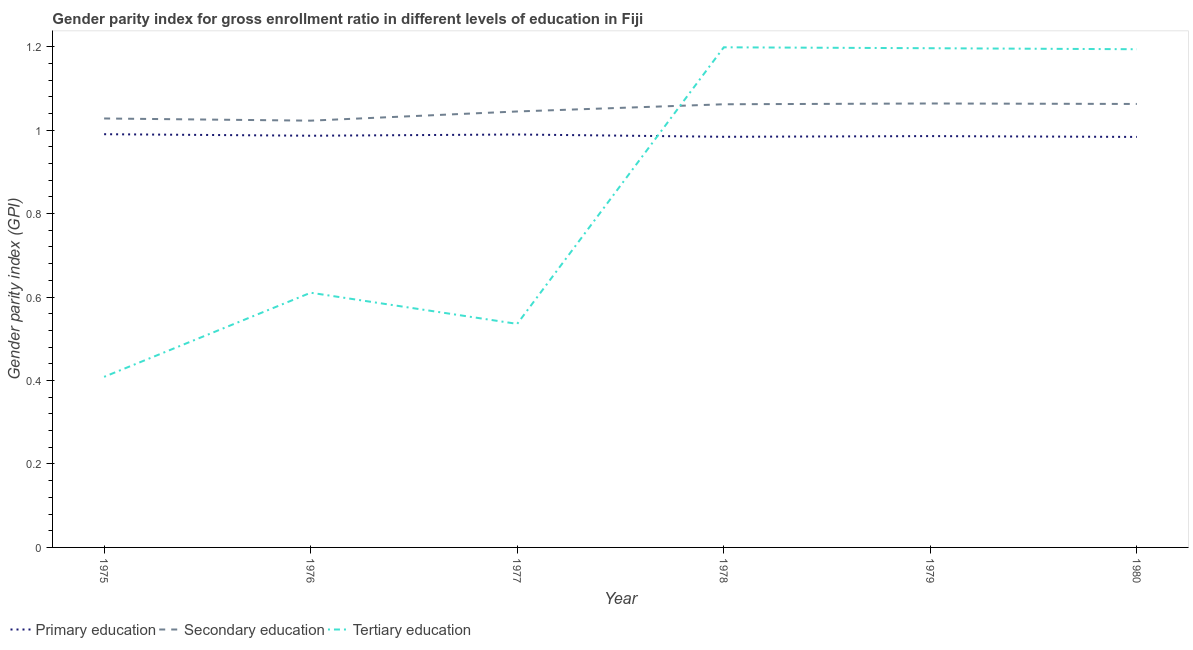How many different coloured lines are there?
Ensure brevity in your answer.  3. What is the gender parity index in tertiary education in 1976?
Your answer should be compact. 0.61. Across all years, what is the maximum gender parity index in secondary education?
Offer a very short reply. 1.06. Across all years, what is the minimum gender parity index in secondary education?
Offer a terse response. 1.02. In which year was the gender parity index in tertiary education maximum?
Ensure brevity in your answer.  1978. In which year was the gender parity index in primary education minimum?
Offer a terse response. 1980. What is the total gender parity index in primary education in the graph?
Offer a terse response. 5.92. What is the difference between the gender parity index in tertiary education in 1977 and that in 1979?
Ensure brevity in your answer.  -0.66. What is the difference between the gender parity index in primary education in 1975 and the gender parity index in tertiary education in 1978?
Your answer should be compact. -0.21. What is the average gender parity index in tertiary education per year?
Offer a terse response. 0.86. In the year 1975, what is the difference between the gender parity index in tertiary education and gender parity index in secondary education?
Ensure brevity in your answer.  -0.62. In how many years, is the gender parity index in secondary education greater than 1.04?
Your response must be concise. 4. What is the ratio of the gender parity index in tertiary education in 1979 to that in 1980?
Offer a very short reply. 1. Is the gender parity index in tertiary education in 1977 less than that in 1978?
Ensure brevity in your answer.  Yes. What is the difference between the highest and the second highest gender parity index in tertiary education?
Provide a short and direct response. 0. What is the difference between the highest and the lowest gender parity index in primary education?
Ensure brevity in your answer.  0.01. Is the sum of the gender parity index in secondary education in 1976 and 1978 greater than the maximum gender parity index in primary education across all years?
Make the answer very short. Yes. Does the gender parity index in secondary education monotonically increase over the years?
Provide a short and direct response. No. Is the gender parity index in secondary education strictly less than the gender parity index in tertiary education over the years?
Your answer should be very brief. No. What is the difference between two consecutive major ticks on the Y-axis?
Provide a short and direct response. 0.2. Are the values on the major ticks of Y-axis written in scientific E-notation?
Make the answer very short. No. Does the graph contain any zero values?
Keep it short and to the point. No. Does the graph contain grids?
Give a very brief answer. No. How are the legend labels stacked?
Offer a terse response. Horizontal. What is the title of the graph?
Ensure brevity in your answer.  Gender parity index for gross enrollment ratio in different levels of education in Fiji. What is the label or title of the X-axis?
Your answer should be very brief. Year. What is the label or title of the Y-axis?
Your answer should be very brief. Gender parity index (GPI). What is the Gender parity index (GPI) of Primary education in 1975?
Offer a terse response. 0.99. What is the Gender parity index (GPI) of Secondary education in 1975?
Provide a succinct answer. 1.03. What is the Gender parity index (GPI) in Tertiary education in 1975?
Offer a terse response. 0.41. What is the Gender parity index (GPI) in Primary education in 1976?
Ensure brevity in your answer.  0.99. What is the Gender parity index (GPI) in Secondary education in 1976?
Ensure brevity in your answer.  1.02. What is the Gender parity index (GPI) in Tertiary education in 1976?
Provide a short and direct response. 0.61. What is the Gender parity index (GPI) of Primary education in 1977?
Give a very brief answer. 0.99. What is the Gender parity index (GPI) of Secondary education in 1977?
Make the answer very short. 1.04. What is the Gender parity index (GPI) of Tertiary education in 1977?
Offer a terse response. 0.54. What is the Gender parity index (GPI) of Primary education in 1978?
Give a very brief answer. 0.98. What is the Gender parity index (GPI) of Secondary education in 1978?
Your answer should be compact. 1.06. What is the Gender parity index (GPI) of Tertiary education in 1978?
Keep it short and to the point. 1.2. What is the Gender parity index (GPI) of Primary education in 1979?
Keep it short and to the point. 0.99. What is the Gender parity index (GPI) of Secondary education in 1979?
Give a very brief answer. 1.06. What is the Gender parity index (GPI) of Tertiary education in 1979?
Keep it short and to the point. 1.2. What is the Gender parity index (GPI) of Primary education in 1980?
Your answer should be very brief. 0.98. What is the Gender parity index (GPI) in Secondary education in 1980?
Make the answer very short. 1.06. What is the Gender parity index (GPI) of Tertiary education in 1980?
Keep it short and to the point. 1.19. Across all years, what is the maximum Gender parity index (GPI) of Primary education?
Your answer should be very brief. 0.99. Across all years, what is the maximum Gender parity index (GPI) in Secondary education?
Give a very brief answer. 1.06. Across all years, what is the maximum Gender parity index (GPI) in Tertiary education?
Offer a terse response. 1.2. Across all years, what is the minimum Gender parity index (GPI) of Primary education?
Your response must be concise. 0.98. Across all years, what is the minimum Gender parity index (GPI) of Secondary education?
Provide a short and direct response. 1.02. Across all years, what is the minimum Gender parity index (GPI) in Tertiary education?
Keep it short and to the point. 0.41. What is the total Gender parity index (GPI) of Primary education in the graph?
Your answer should be very brief. 5.92. What is the total Gender parity index (GPI) of Secondary education in the graph?
Keep it short and to the point. 6.28. What is the total Gender parity index (GPI) in Tertiary education in the graph?
Keep it short and to the point. 5.14. What is the difference between the Gender parity index (GPI) of Primary education in 1975 and that in 1976?
Give a very brief answer. 0. What is the difference between the Gender parity index (GPI) in Secondary education in 1975 and that in 1976?
Your answer should be very brief. 0.01. What is the difference between the Gender parity index (GPI) in Tertiary education in 1975 and that in 1976?
Make the answer very short. -0.2. What is the difference between the Gender parity index (GPI) in Primary education in 1975 and that in 1977?
Your answer should be very brief. 0. What is the difference between the Gender parity index (GPI) in Secondary education in 1975 and that in 1977?
Give a very brief answer. -0.02. What is the difference between the Gender parity index (GPI) of Tertiary education in 1975 and that in 1977?
Provide a succinct answer. -0.13. What is the difference between the Gender parity index (GPI) in Primary education in 1975 and that in 1978?
Make the answer very short. 0.01. What is the difference between the Gender parity index (GPI) in Secondary education in 1975 and that in 1978?
Provide a succinct answer. -0.03. What is the difference between the Gender parity index (GPI) of Tertiary education in 1975 and that in 1978?
Keep it short and to the point. -0.79. What is the difference between the Gender parity index (GPI) in Primary education in 1975 and that in 1979?
Your response must be concise. 0. What is the difference between the Gender parity index (GPI) of Secondary education in 1975 and that in 1979?
Your response must be concise. -0.04. What is the difference between the Gender parity index (GPI) in Tertiary education in 1975 and that in 1979?
Offer a very short reply. -0.79. What is the difference between the Gender parity index (GPI) in Primary education in 1975 and that in 1980?
Offer a very short reply. 0.01. What is the difference between the Gender parity index (GPI) of Secondary education in 1975 and that in 1980?
Ensure brevity in your answer.  -0.03. What is the difference between the Gender parity index (GPI) in Tertiary education in 1975 and that in 1980?
Keep it short and to the point. -0.79. What is the difference between the Gender parity index (GPI) in Primary education in 1976 and that in 1977?
Your answer should be compact. -0. What is the difference between the Gender parity index (GPI) in Secondary education in 1976 and that in 1977?
Offer a very short reply. -0.02. What is the difference between the Gender parity index (GPI) of Tertiary education in 1976 and that in 1977?
Your answer should be compact. 0.07. What is the difference between the Gender parity index (GPI) in Primary education in 1976 and that in 1978?
Your response must be concise. 0. What is the difference between the Gender parity index (GPI) of Secondary education in 1976 and that in 1978?
Keep it short and to the point. -0.04. What is the difference between the Gender parity index (GPI) of Tertiary education in 1976 and that in 1978?
Keep it short and to the point. -0.59. What is the difference between the Gender parity index (GPI) in Primary education in 1976 and that in 1979?
Ensure brevity in your answer.  0. What is the difference between the Gender parity index (GPI) of Secondary education in 1976 and that in 1979?
Offer a terse response. -0.04. What is the difference between the Gender parity index (GPI) in Tertiary education in 1976 and that in 1979?
Your response must be concise. -0.59. What is the difference between the Gender parity index (GPI) of Primary education in 1976 and that in 1980?
Your answer should be compact. 0. What is the difference between the Gender parity index (GPI) of Secondary education in 1976 and that in 1980?
Provide a succinct answer. -0.04. What is the difference between the Gender parity index (GPI) of Tertiary education in 1976 and that in 1980?
Provide a short and direct response. -0.58. What is the difference between the Gender parity index (GPI) of Primary education in 1977 and that in 1978?
Keep it short and to the point. 0.01. What is the difference between the Gender parity index (GPI) of Secondary education in 1977 and that in 1978?
Provide a succinct answer. -0.02. What is the difference between the Gender parity index (GPI) in Tertiary education in 1977 and that in 1978?
Offer a very short reply. -0.66. What is the difference between the Gender parity index (GPI) in Primary education in 1977 and that in 1979?
Keep it short and to the point. 0. What is the difference between the Gender parity index (GPI) in Secondary education in 1977 and that in 1979?
Keep it short and to the point. -0.02. What is the difference between the Gender parity index (GPI) in Tertiary education in 1977 and that in 1979?
Provide a short and direct response. -0.66. What is the difference between the Gender parity index (GPI) of Primary education in 1977 and that in 1980?
Your response must be concise. 0.01. What is the difference between the Gender parity index (GPI) in Secondary education in 1977 and that in 1980?
Offer a terse response. -0.02. What is the difference between the Gender parity index (GPI) in Tertiary education in 1977 and that in 1980?
Offer a very short reply. -0.66. What is the difference between the Gender parity index (GPI) in Primary education in 1978 and that in 1979?
Offer a terse response. -0. What is the difference between the Gender parity index (GPI) of Secondary education in 1978 and that in 1979?
Make the answer very short. -0. What is the difference between the Gender parity index (GPI) in Tertiary education in 1978 and that in 1979?
Offer a terse response. 0. What is the difference between the Gender parity index (GPI) of Primary education in 1978 and that in 1980?
Make the answer very short. 0. What is the difference between the Gender parity index (GPI) in Secondary education in 1978 and that in 1980?
Give a very brief answer. -0. What is the difference between the Gender parity index (GPI) of Tertiary education in 1978 and that in 1980?
Ensure brevity in your answer.  0. What is the difference between the Gender parity index (GPI) in Primary education in 1979 and that in 1980?
Ensure brevity in your answer.  0. What is the difference between the Gender parity index (GPI) in Secondary education in 1979 and that in 1980?
Your answer should be compact. 0. What is the difference between the Gender parity index (GPI) in Tertiary education in 1979 and that in 1980?
Ensure brevity in your answer.  0. What is the difference between the Gender parity index (GPI) of Primary education in 1975 and the Gender parity index (GPI) of Secondary education in 1976?
Ensure brevity in your answer.  -0.03. What is the difference between the Gender parity index (GPI) of Primary education in 1975 and the Gender parity index (GPI) of Tertiary education in 1976?
Offer a very short reply. 0.38. What is the difference between the Gender parity index (GPI) in Secondary education in 1975 and the Gender parity index (GPI) in Tertiary education in 1976?
Give a very brief answer. 0.42. What is the difference between the Gender parity index (GPI) in Primary education in 1975 and the Gender parity index (GPI) in Secondary education in 1977?
Provide a short and direct response. -0.05. What is the difference between the Gender parity index (GPI) of Primary education in 1975 and the Gender parity index (GPI) of Tertiary education in 1977?
Make the answer very short. 0.45. What is the difference between the Gender parity index (GPI) in Secondary education in 1975 and the Gender parity index (GPI) in Tertiary education in 1977?
Give a very brief answer. 0.49. What is the difference between the Gender parity index (GPI) in Primary education in 1975 and the Gender parity index (GPI) in Secondary education in 1978?
Offer a very short reply. -0.07. What is the difference between the Gender parity index (GPI) in Primary education in 1975 and the Gender parity index (GPI) in Tertiary education in 1978?
Offer a terse response. -0.21. What is the difference between the Gender parity index (GPI) in Secondary education in 1975 and the Gender parity index (GPI) in Tertiary education in 1978?
Keep it short and to the point. -0.17. What is the difference between the Gender parity index (GPI) of Primary education in 1975 and the Gender parity index (GPI) of Secondary education in 1979?
Your answer should be compact. -0.07. What is the difference between the Gender parity index (GPI) in Primary education in 1975 and the Gender parity index (GPI) in Tertiary education in 1979?
Your answer should be compact. -0.21. What is the difference between the Gender parity index (GPI) of Secondary education in 1975 and the Gender parity index (GPI) of Tertiary education in 1979?
Offer a very short reply. -0.17. What is the difference between the Gender parity index (GPI) of Primary education in 1975 and the Gender parity index (GPI) of Secondary education in 1980?
Keep it short and to the point. -0.07. What is the difference between the Gender parity index (GPI) of Primary education in 1975 and the Gender parity index (GPI) of Tertiary education in 1980?
Provide a short and direct response. -0.2. What is the difference between the Gender parity index (GPI) in Secondary education in 1975 and the Gender parity index (GPI) in Tertiary education in 1980?
Provide a short and direct response. -0.17. What is the difference between the Gender parity index (GPI) of Primary education in 1976 and the Gender parity index (GPI) of Secondary education in 1977?
Your answer should be very brief. -0.06. What is the difference between the Gender parity index (GPI) of Primary education in 1976 and the Gender parity index (GPI) of Tertiary education in 1977?
Your answer should be very brief. 0.45. What is the difference between the Gender parity index (GPI) in Secondary education in 1976 and the Gender parity index (GPI) in Tertiary education in 1977?
Give a very brief answer. 0.49. What is the difference between the Gender parity index (GPI) of Primary education in 1976 and the Gender parity index (GPI) of Secondary education in 1978?
Ensure brevity in your answer.  -0.08. What is the difference between the Gender parity index (GPI) in Primary education in 1976 and the Gender parity index (GPI) in Tertiary education in 1978?
Provide a succinct answer. -0.21. What is the difference between the Gender parity index (GPI) in Secondary education in 1976 and the Gender parity index (GPI) in Tertiary education in 1978?
Give a very brief answer. -0.18. What is the difference between the Gender parity index (GPI) of Primary education in 1976 and the Gender parity index (GPI) of Secondary education in 1979?
Your response must be concise. -0.08. What is the difference between the Gender parity index (GPI) in Primary education in 1976 and the Gender parity index (GPI) in Tertiary education in 1979?
Give a very brief answer. -0.21. What is the difference between the Gender parity index (GPI) in Secondary education in 1976 and the Gender parity index (GPI) in Tertiary education in 1979?
Your answer should be very brief. -0.17. What is the difference between the Gender parity index (GPI) of Primary education in 1976 and the Gender parity index (GPI) of Secondary education in 1980?
Offer a terse response. -0.08. What is the difference between the Gender parity index (GPI) in Primary education in 1976 and the Gender parity index (GPI) in Tertiary education in 1980?
Keep it short and to the point. -0.21. What is the difference between the Gender parity index (GPI) in Secondary education in 1976 and the Gender parity index (GPI) in Tertiary education in 1980?
Your answer should be very brief. -0.17. What is the difference between the Gender parity index (GPI) in Primary education in 1977 and the Gender parity index (GPI) in Secondary education in 1978?
Provide a short and direct response. -0.07. What is the difference between the Gender parity index (GPI) in Primary education in 1977 and the Gender parity index (GPI) in Tertiary education in 1978?
Your response must be concise. -0.21. What is the difference between the Gender parity index (GPI) of Secondary education in 1977 and the Gender parity index (GPI) of Tertiary education in 1978?
Your response must be concise. -0.15. What is the difference between the Gender parity index (GPI) of Primary education in 1977 and the Gender parity index (GPI) of Secondary education in 1979?
Offer a very short reply. -0.07. What is the difference between the Gender parity index (GPI) of Primary education in 1977 and the Gender parity index (GPI) of Tertiary education in 1979?
Offer a very short reply. -0.21. What is the difference between the Gender parity index (GPI) of Secondary education in 1977 and the Gender parity index (GPI) of Tertiary education in 1979?
Provide a short and direct response. -0.15. What is the difference between the Gender parity index (GPI) of Primary education in 1977 and the Gender parity index (GPI) of Secondary education in 1980?
Offer a very short reply. -0.07. What is the difference between the Gender parity index (GPI) of Primary education in 1977 and the Gender parity index (GPI) of Tertiary education in 1980?
Ensure brevity in your answer.  -0.2. What is the difference between the Gender parity index (GPI) of Secondary education in 1977 and the Gender parity index (GPI) of Tertiary education in 1980?
Give a very brief answer. -0.15. What is the difference between the Gender parity index (GPI) in Primary education in 1978 and the Gender parity index (GPI) in Secondary education in 1979?
Give a very brief answer. -0.08. What is the difference between the Gender parity index (GPI) of Primary education in 1978 and the Gender parity index (GPI) of Tertiary education in 1979?
Your response must be concise. -0.21. What is the difference between the Gender parity index (GPI) of Secondary education in 1978 and the Gender parity index (GPI) of Tertiary education in 1979?
Your answer should be compact. -0.13. What is the difference between the Gender parity index (GPI) of Primary education in 1978 and the Gender parity index (GPI) of Secondary education in 1980?
Your answer should be very brief. -0.08. What is the difference between the Gender parity index (GPI) of Primary education in 1978 and the Gender parity index (GPI) of Tertiary education in 1980?
Offer a terse response. -0.21. What is the difference between the Gender parity index (GPI) in Secondary education in 1978 and the Gender parity index (GPI) in Tertiary education in 1980?
Keep it short and to the point. -0.13. What is the difference between the Gender parity index (GPI) in Primary education in 1979 and the Gender parity index (GPI) in Secondary education in 1980?
Your answer should be very brief. -0.08. What is the difference between the Gender parity index (GPI) of Primary education in 1979 and the Gender parity index (GPI) of Tertiary education in 1980?
Offer a terse response. -0.21. What is the difference between the Gender parity index (GPI) of Secondary education in 1979 and the Gender parity index (GPI) of Tertiary education in 1980?
Offer a terse response. -0.13. What is the average Gender parity index (GPI) in Primary education per year?
Provide a succinct answer. 0.99. What is the average Gender parity index (GPI) of Secondary education per year?
Provide a short and direct response. 1.05. What is the average Gender parity index (GPI) in Tertiary education per year?
Offer a terse response. 0.86. In the year 1975, what is the difference between the Gender parity index (GPI) of Primary education and Gender parity index (GPI) of Secondary education?
Offer a terse response. -0.04. In the year 1975, what is the difference between the Gender parity index (GPI) in Primary education and Gender parity index (GPI) in Tertiary education?
Your response must be concise. 0.58. In the year 1975, what is the difference between the Gender parity index (GPI) of Secondary education and Gender parity index (GPI) of Tertiary education?
Offer a very short reply. 0.62. In the year 1976, what is the difference between the Gender parity index (GPI) of Primary education and Gender parity index (GPI) of Secondary education?
Provide a short and direct response. -0.04. In the year 1976, what is the difference between the Gender parity index (GPI) of Primary education and Gender parity index (GPI) of Tertiary education?
Give a very brief answer. 0.38. In the year 1976, what is the difference between the Gender parity index (GPI) in Secondary education and Gender parity index (GPI) in Tertiary education?
Your response must be concise. 0.41. In the year 1977, what is the difference between the Gender parity index (GPI) of Primary education and Gender parity index (GPI) of Secondary education?
Give a very brief answer. -0.06. In the year 1977, what is the difference between the Gender parity index (GPI) of Primary education and Gender parity index (GPI) of Tertiary education?
Provide a short and direct response. 0.45. In the year 1977, what is the difference between the Gender parity index (GPI) in Secondary education and Gender parity index (GPI) in Tertiary education?
Your answer should be compact. 0.51. In the year 1978, what is the difference between the Gender parity index (GPI) of Primary education and Gender parity index (GPI) of Secondary education?
Give a very brief answer. -0.08. In the year 1978, what is the difference between the Gender parity index (GPI) of Primary education and Gender parity index (GPI) of Tertiary education?
Your answer should be compact. -0.21. In the year 1978, what is the difference between the Gender parity index (GPI) in Secondary education and Gender parity index (GPI) in Tertiary education?
Make the answer very short. -0.14. In the year 1979, what is the difference between the Gender parity index (GPI) in Primary education and Gender parity index (GPI) in Secondary education?
Your answer should be very brief. -0.08. In the year 1979, what is the difference between the Gender parity index (GPI) of Primary education and Gender parity index (GPI) of Tertiary education?
Offer a very short reply. -0.21. In the year 1979, what is the difference between the Gender parity index (GPI) in Secondary education and Gender parity index (GPI) in Tertiary education?
Your answer should be compact. -0.13. In the year 1980, what is the difference between the Gender parity index (GPI) of Primary education and Gender parity index (GPI) of Secondary education?
Provide a succinct answer. -0.08. In the year 1980, what is the difference between the Gender parity index (GPI) of Primary education and Gender parity index (GPI) of Tertiary education?
Keep it short and to the point. -0.21. In the year 1980, what is the difference between the Gender parity index (GPI) in Secondary education and Gender parity index (GPI) in Tertiary education?
Provide a short and direct response. -0.13. What is the ratio of the Gender parity index (GPI) in Secondary education in 1975 to that in 1976?
Your response must be concise. 1.01. What is the ratio of the Gender parity index (GPI) of Tertiary education in 1975 to that in 1976?
Ensure brevity in your answer.  0.67. What is the ratio of the Gender parity index (GPI) in Secondary education in 1975 to that in 1977?
Your response must be concise. 0.98. What is the ratio of the Gender parity index (GPI) in Tertiary education in 1975 to that in 1977?
Provide a succinct answer. 0.76. What is the ratio of the Gender parity index (GPI) of Secondary education in 1975 to that in 1978?
Give a very brief answer. 0.97. What is the ratio of the Gender parity index (GPI) in Tertiary education in 1975 to that in 1978?
Provide a succinct answer. 0.34. What is the ratio of the Gender parity index (GPI) of Secondary education in 1975 to that in 1979?
Make the answer very short. 0.97. What is the ratio of the Gender parity index (GPI) in Tertiary education in 1975 to that in 1979?
Your response must be concise. 0.34. What is the ratio of the Gender parity index (GPI) of Primary education in 1975 to that in 1980?
Provide a succinct answer. 1.01. What is the ratio of the Gender parity index (GPI) in Secondary education in 1975 to that in 1980?
Keep it short and to the point. 0.97. What is the ratio of the Gender parity index (GPI) in Tertiary education in 1975 to that in 1980?
Provide a short and direct response. 0.34. What is the ratio of the Gender parity index (GPI) of Secondary education in 1976 to that in 1977?
Your response must be concise. 0.98. What is the ratio of the Gender parity index (GPI) in Tertiary education in 1976 to that in 1977?
Ensure brevity in your answer.  1.14. What is the ratio of the Gender parity index (GPI) of Secondary education in 1976 to that in 1978?
Offer a very short reply. 0.96. What is the ratio of the Gender parity index (GPI) of Tertiary education in 1976 to that in 1978?
Your answer should be compact. 0.51. What is the ratio of the Gender parity index (GPI) of Secondary education in 1976 to that in 1979?
Your response must be concise. 0.96. What is the ratio of the Gender parity index (GPI) in Tertiary education in 1976 to that in 1979?
Your answer should be compact. 0.51. What is the ratio of the Gender parity index (GPI) of Secondary education in 1976 to that in 1980?
Ensure brevity in your answer.  0.96. What is the ratio of the Gender parity index (GPI) of Tertiary education in 1976 to that in 1980?
Make the answer very short. 0.51. What is the ratio of the Gender parity index (GPI) of Primary education in 1977 to that in 1978?
Provide a short and direct response. 1.01. What is the ratio of the Gender parity index (GPI) of Secondary education in 1977 to that in 1978?
Your answer should be compact. 0.98. What is the ratio of the Gender parity index (GPI) of Tertiary education in 1977 to that in 1978?
Your answer should be compact. 0.45. What is the ratio of the Gender parity index (GPI) of Tertiary education in 1977 to that in 1979?
Give a very brief answer. 0.45. What is the ratio of the Gender parity index (GPI) in Primary education in 1977 to that in 1980?
Provide a short and direct response. 1.01. What is the ratio of the Gender parity index (GPI) of Secondary education in 1977 to that in 1980?
Ensure brevity in your answer.  0.98. What is the ratio of the Gender parity index (GPI) in Tertiary education in 1977 to that in 1980?
Your response must be concise. 0.45. What is the ratio of the Gender parity index (GPI) of Secondary education in 1978 to that in 1979?
Offer a very short reply. 1. What is the ratio of the Gender parity index (GPI) of Tertiary education in 1978 to that in 1979?
Ensure brevity in your answer.  1. What is the ratio of the Gender parity index (GPI) in Tertiary education in 1978 to that in 1980?
Offer a terse response. 1. What is the ratio of the Gender parity index (GPI) in Primary education in 1979 to that in 1980?
Keep it short and to the point. 1. What is the ratio of the Gender parity index (GPI) of Secondary education in 1979 to that in 1980?
Offer a terse response. 1. What is the ratio of the Gender parity index (GPI) in Tertiary education in 1979 to that in 1980?
Ensure brevity in your answer.  1. What is the difference between the highest and the second highest Gender parity index (GPI) of Primary education?
Offer a very short reply. 0. What is the difference between the highest and the second highest Gender parity index (GPI) of Secondary education?
Ensure brevity in your answer.  0. What is the difference between the highest and the second highest Gender parity index (GPI) in Tertiary education?
Give a very brief answer. 0. What is the difference between the highest and the lowest Gender parity index (GPI) in Primary education?
Offer a very short reply. 0.01. What is the difference between the highest and the lowest Gender parity index (GPI) in Secondary education?
Offer a very short reply. 0.04. What is the difference between the highest and the lowest Gender parity index (GPI) of Tertiary education?
Your response must be concise. 0.79. 